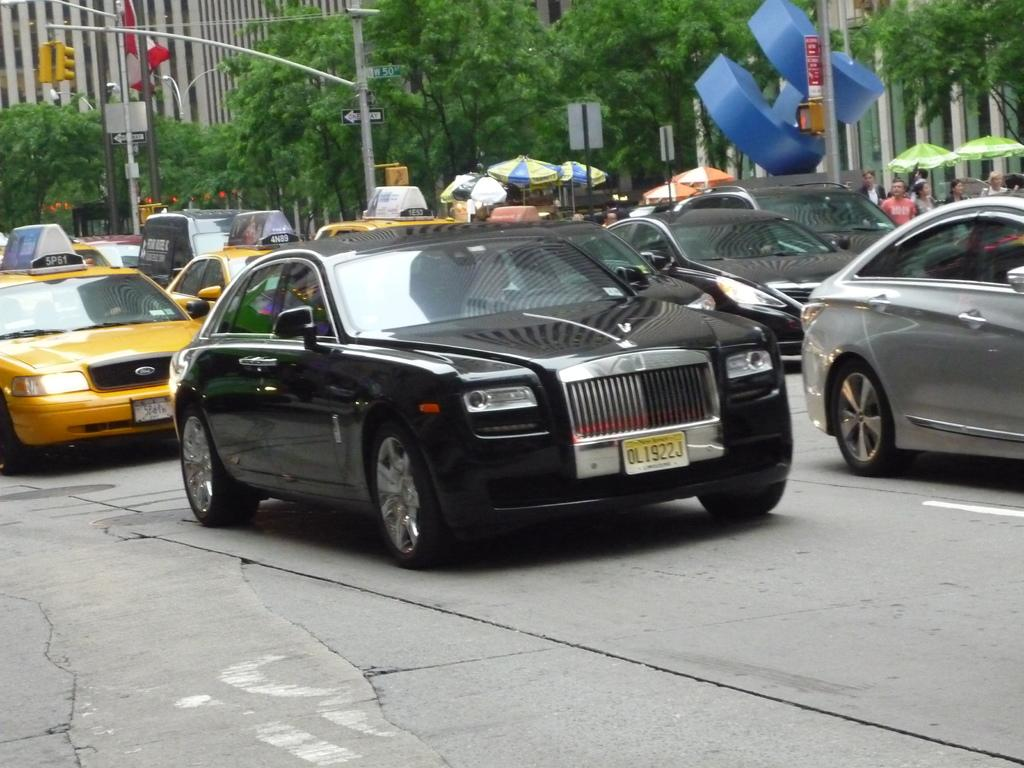<image>
Give a short and clear explanation of the subsequent image. Cars and taxis in traffic with a Rolls Royce with a license plate from New Jersey. 